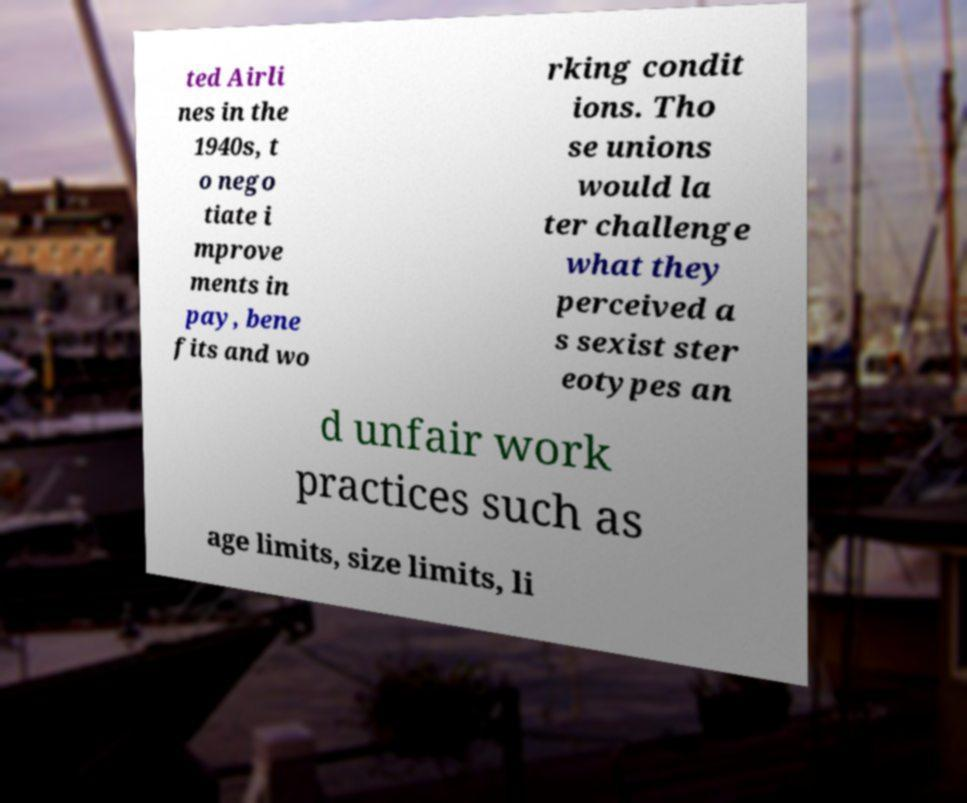Can you read and provide the text displayed in the image?This photo seems to have some interesting text. Can you extract and type it out for me? ted Airli nes in the 1940s, t o nego tiate i mprove ments in pay, bene fits and wo rking condit ions. Tho se unions would la ter challenge what they perceived a s sexist ster eotypes an d unfair work practices such as age limits, size limits, li 